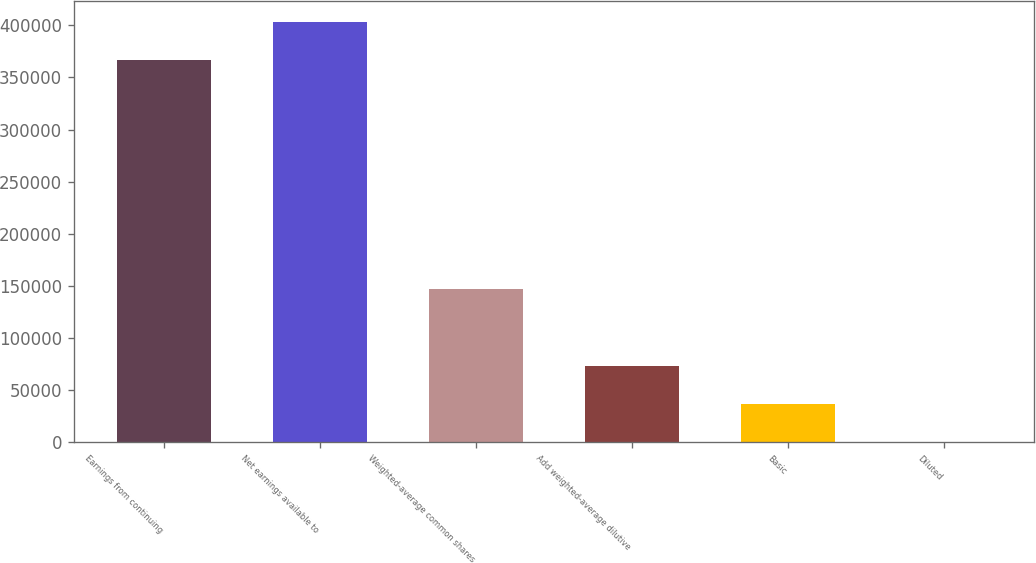Convert chart to OTSL. <chart><loc_0><loc_0><loc_500><loc_500><bar_chart><fcel>Earnings from continuing<fcel>Net earnings available to<fcel>Weighted-average common shares<fcel>Add weighted-average dilutive<fcel>Basic<fcel>Diluted<nl><fcel>366681<fcel>403349<fcel>146675<fcel>73340.2<fcel>36672.7<fcel>5.07<nl></chart> 